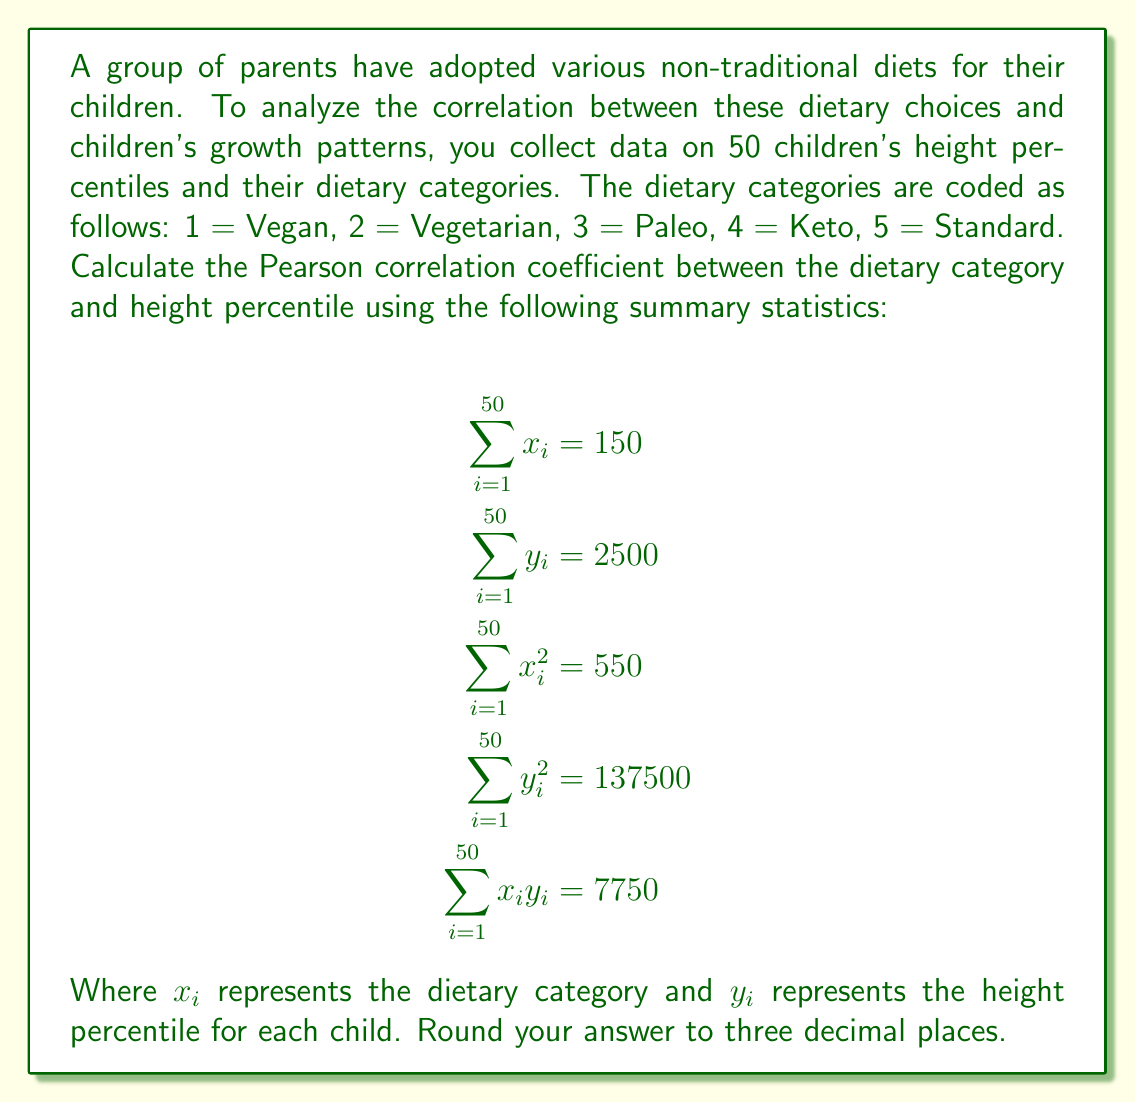Can you answer this question? To calculate the Pearson correlation coefficient, we'll use the formula:

$$r = \frac{n\sum x_iy_i - (\sum x_i)(\sum y_i)}{\sqrt{[n\sum x_i^2 - (\sum x_i)^2][n\sum y_i^2 - (\sum y_i)^2]}}$$

Where $n$ is the number of data points (50 in this case).

Step 1: Calculate the numerator
$$n\sum x_iy_i - (\sum x_i)(\sum y_i) = 50(7750) - (150)(2500) = 387500 - 375000 = 12500$$

Step 2: Calculate the first part of the denominator
$$n\sum x_i^2 - (\sum x_i)^2 = 50(550) - (150)^2 = 27500 - 22500 = 5000$$

Step 3: Calculate the second part of the denominator
$$n\sum y_i^2 - (\sum y_i)^2 = 50(137500) - (2500)^2 = 6875000 - 6250000 = 625000$$

Step 4: Multiply the results from steps 2 and 3
$$5000 * 625000 = 3125000000$$

Step 5: Take the square root of the result from step 4
$$\sqrt{3125000000} = 55901.699$$

Step 6: Divide the numerator by the denominator
$$\frac{12500}{55901.699} = 0.22361$$

Step 7: Round to three decimal places
$$0.224$$
Answer: 0.224 